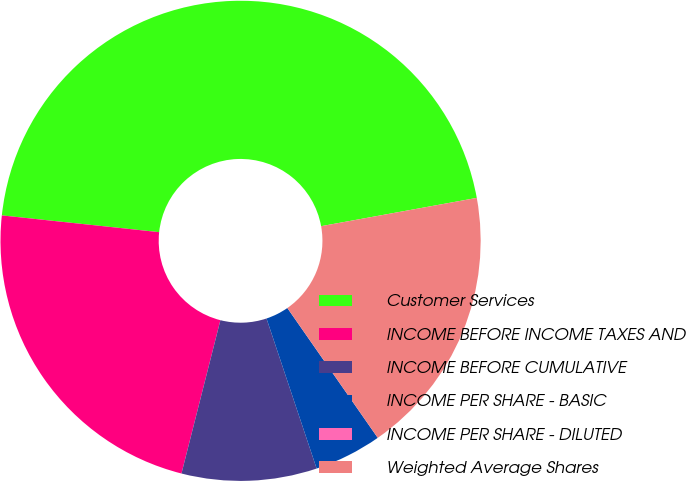<chart> <loc_0><loc_0><loc_500><loc_500><pie_chart><fcel>Customer Services<fcel>INCOME BEFORE INCOME TAXES AND<fcel>INCOME BEFORE CUMULATIVE<fcel>INCOME PER SHARE - BASIC<fcel>INCOME PER SHARE - DILUTED<fcel>Weighted Average Shares<nl><fcel>45.45%<fcel>22.73%<fcel>9.09%<fcel>4.55%<fcel>0.0%<fcel>18.18%<nl></chart> 